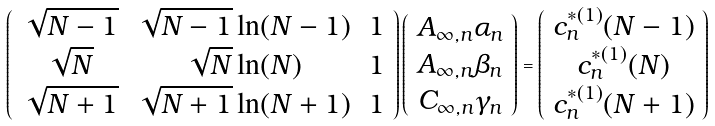<formula> <loc_0><loc_0><loc_500><loc_500>\left ( \begin{array} { c c c } \sqrt { N - 1 } & \sqrt { N - 1 } \ln ( N - 1 ) & 1 \\ \sqrt { N } & \sqrt { N } \ln ( N ) & 1 \\ \sqrt { N + 1 } & \sqrt { N + 1 } \ln ( N + 1 ) & 1 \end{array} \right ) \left ( \begin{array} { c } A _ { \infty , n } \alpha _ { n } \\ A _ { \infty , n } \beta _ { n } \\ C _ { \infty , n } \gamma _ { n } \end{array} \right ) = \left ( \begin{array} { c } c _ { n } ^ { * ( 1 ) } ( N - 1 ) \\ c _ { n } ^ { * ( 1 ) } ( N ) \\ c _ { n } ^ { * ( 1 ) } ( N + 1 ) \end{array} \right )</formula> 